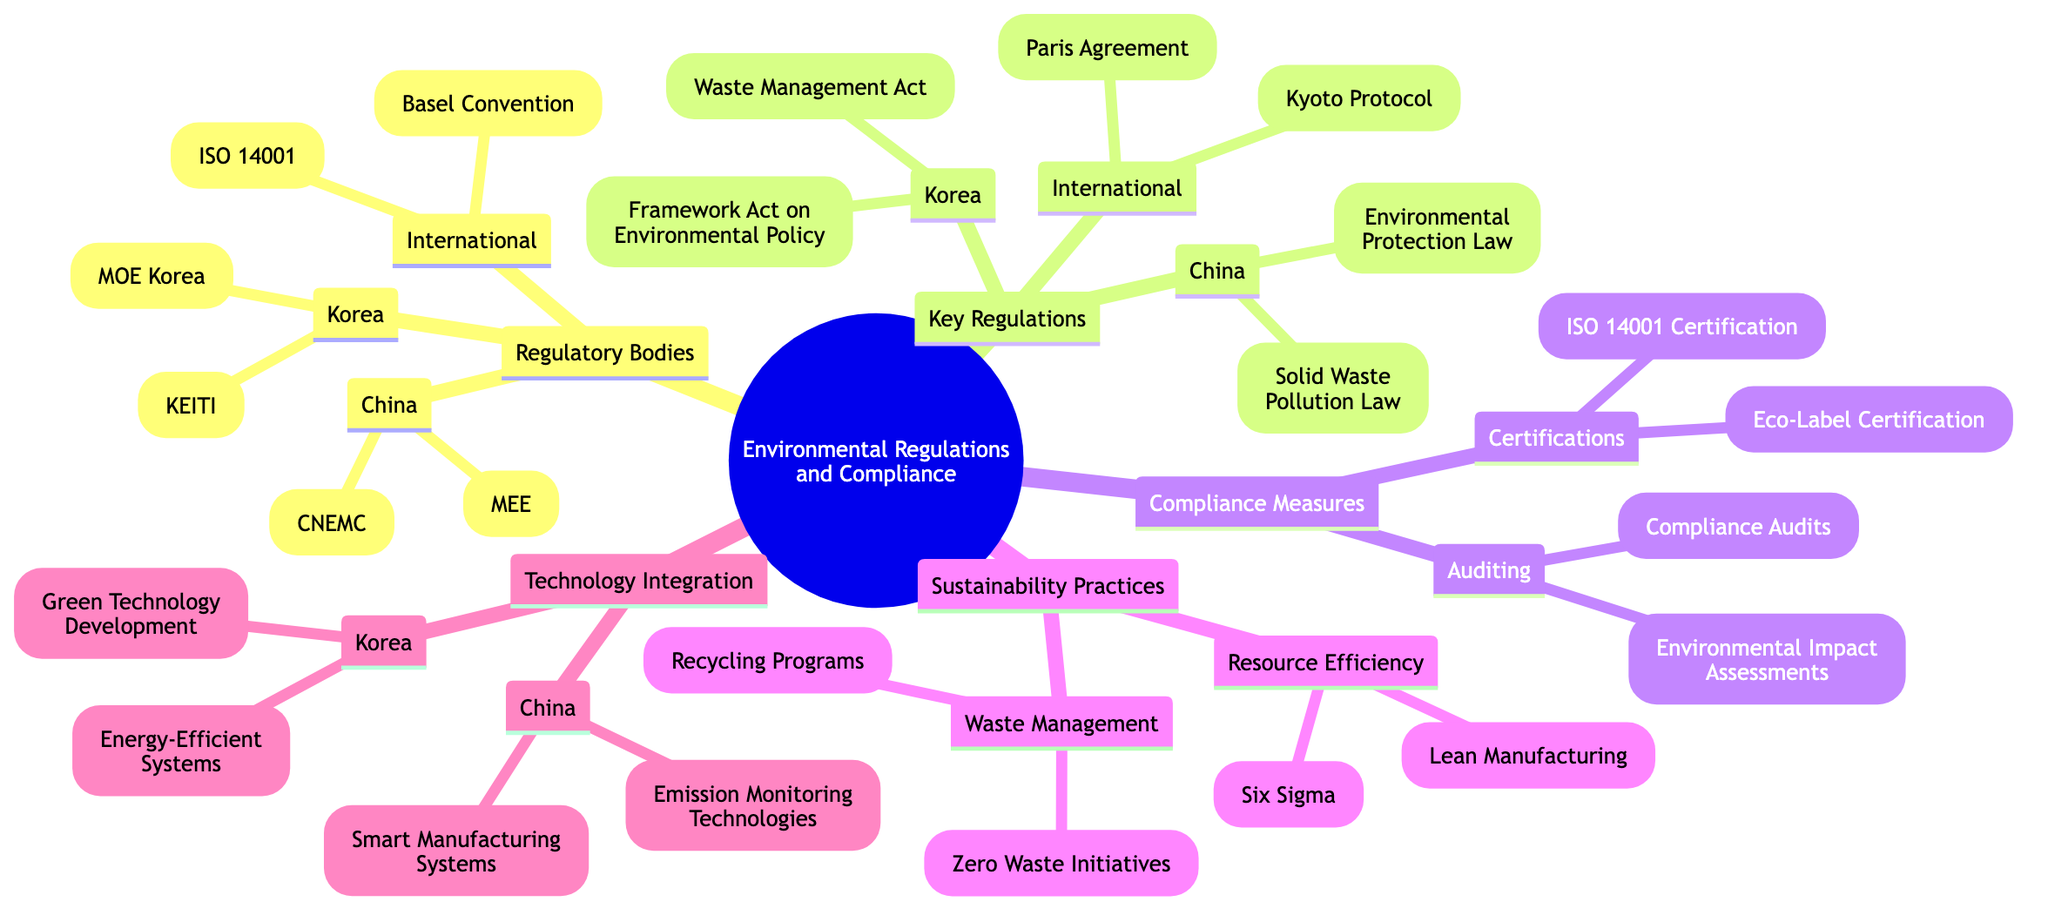What are the two international regulatory bodies listed? The diagram specifies two international regulatory bodies under "Regulatory Bodies" — ISO 14001 and Basel Convention.
Answer: ISO 14001, Basel Convention How many key regulations are listed for China? Under "Key Regulations," China has two entries: Environmental Protection Law and Solid Waste Pollution Prevention and Control Law, making a total of two regulations listed.
Answer: 2 Which compliance measure involves audits? The first section under "Compliance Measures" is "Auditing," which includes Environmental Impact Assessments and Compliance Audits, indicating that auditing is indeed a compliance measure.
Answer: Auditing What sustainability practice focuses on efficient resource use? The diagram mentions "Resource Efficiency" under "Sustainability Practices," which includes Lean Manufacturing and Six Sigma, highlighting practices for efficient resource use.
Answer: Resource Efficiency Which technology integration is associated with China? The "Technology Integration" section specifically pertaining to China includes Smart Manufacturing Systems and Emission Monitoring Technologies, identifying these as associated technological solutions.
Answer: Smart Manufacturing Systems, Emission Monitoring Technologies How many certifications are mentioned under Compliance Measures? The "Certifications" section under "Compliance Measures" lists two types of certifications: ISO 14001 Certification and Eco-Label Certification, resulting in a total of two certifications.
Answer: 2 Which act is highlighted under Korean Key Regulations? Under the "Key Regulations" section designated for Korea, the "Framework Act on Environmental Policy" is mentioned as one of the key acts, indicating its importance in the regulatory landscape.
Answer: Framework Act on Environmental Policy What is a sustainability practice included in Waste Management? The diagram mentions "Zero Waste Initiatives" under the "Waste Management" subsection of "Sustainability Practices" as a specific initiative aimed at achieving sustainability.
Answer: Zero Waste Initiatives Which regulatory body is specific to Korea? Under "Regulatory Bodies," the diagram lists "Ministry of Environment (MOE) Korea" as a specific regulatory body relevant to Korea, signifying its regulatory role.
Answer: Ministry of Environment (MOE) Korea 